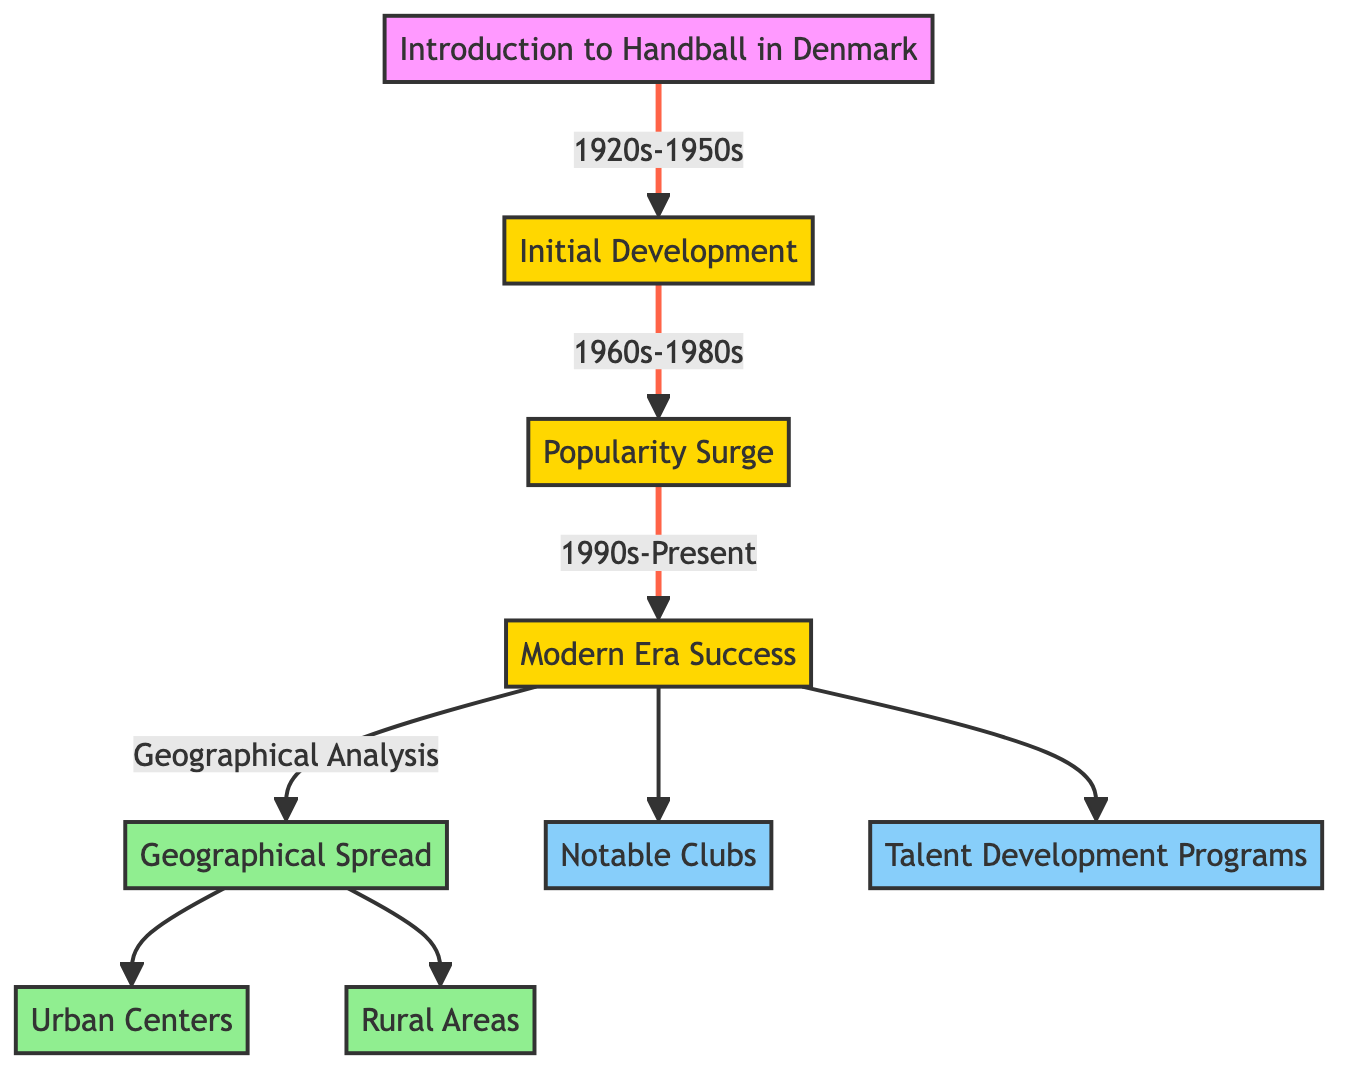What are the time periods shown in the diagram? The diagram outlines three distinct time periods for the rise of handball in Denmark: 1920s-1950s, 1960s-1980s, and 1990s-Present. These periods correspond to different stages of development, popularity, and modern success.
Answer: 1920s-1950s, 1960s-1980s, 1990s-Present How many regions are highlighted in the geographical spread? Based on the diagram, there are three regions indicated under geographical spread: Urban Centers, Rural Areas, and one generic region labeled Geographical Spread. These reflect the areas where handball has gained popularity.
Answer: 3 Which era follows the Initial Development? The diagram shows a sequential flow where after the Initial Development (1920s-1950s), the next era indicated is the Popularity Surge (1960s-1980s).
Answer: Popularity Surge What aspect is directly linked to Modern Era Success? The Modern Era Success (1990s-Present) is directly connected to two aspects: Notable Clubs and Talent Development Programs. This signifies the importance of clubs and programs in the success of handball during this period.
Answer: Notable Clubs, Talent Development Programs What does the diagram suggest about the development of handball in rural areas compared to urban centers? Although the diagram does not provide a direct comparison, it indicates that both Urban Centers and Rural Areas are part of the geographical spread of handball. This suggests that while handball is popular in cities, it also has a presence in rural areas, indicating widespread interest.
Answer: Widespread interest Which aspect significantly contributed to the popularity of handball in Denmark? The diagram includes Talent Development Programs as a pivotal aspect contributing to the popularity of handball in Denmark. These programs are crucial for nurturing new talents and promoting the sport.
Answer: Talent Development Programs What is the primary focus of the graph? The primary focus of the graph is on the rise in popularity of handball in Denmark, covering various historical and demographic aspects through timelines and geographical analysis.
Answer: Rise in popularity How does the flow of the diagram structure the history of handball? The flow of the diagram arranges the history of handball in a chronological sequence, starting from its introduction to its development over decades and culminating in modern success and geographical analysis, which shows its evolution clearly over time.
Answer: Chronological sequence 